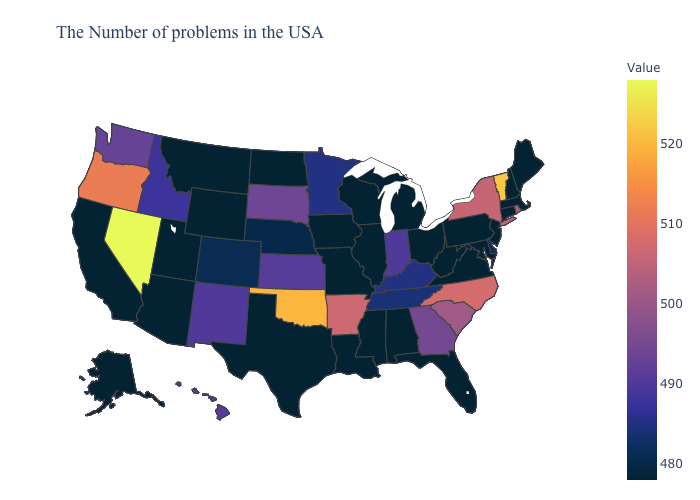Which states have the highest value in the USA?
Write a very short answer. Nevada. Does the map have missing data?
Concise answer only. No. Which states have the highest value in the USA?
Concise answer only. Nevada. 